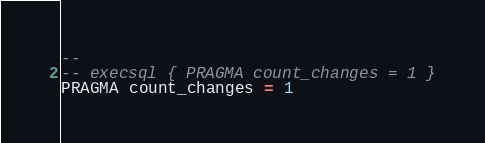Convert code to text. <code><loc_0><loc_0><loc_500><loc_500><_SQL_>-- 
-- execsql { PRAGMA count_changes = 1 }
PRAGMA count_changes = 1</code> 